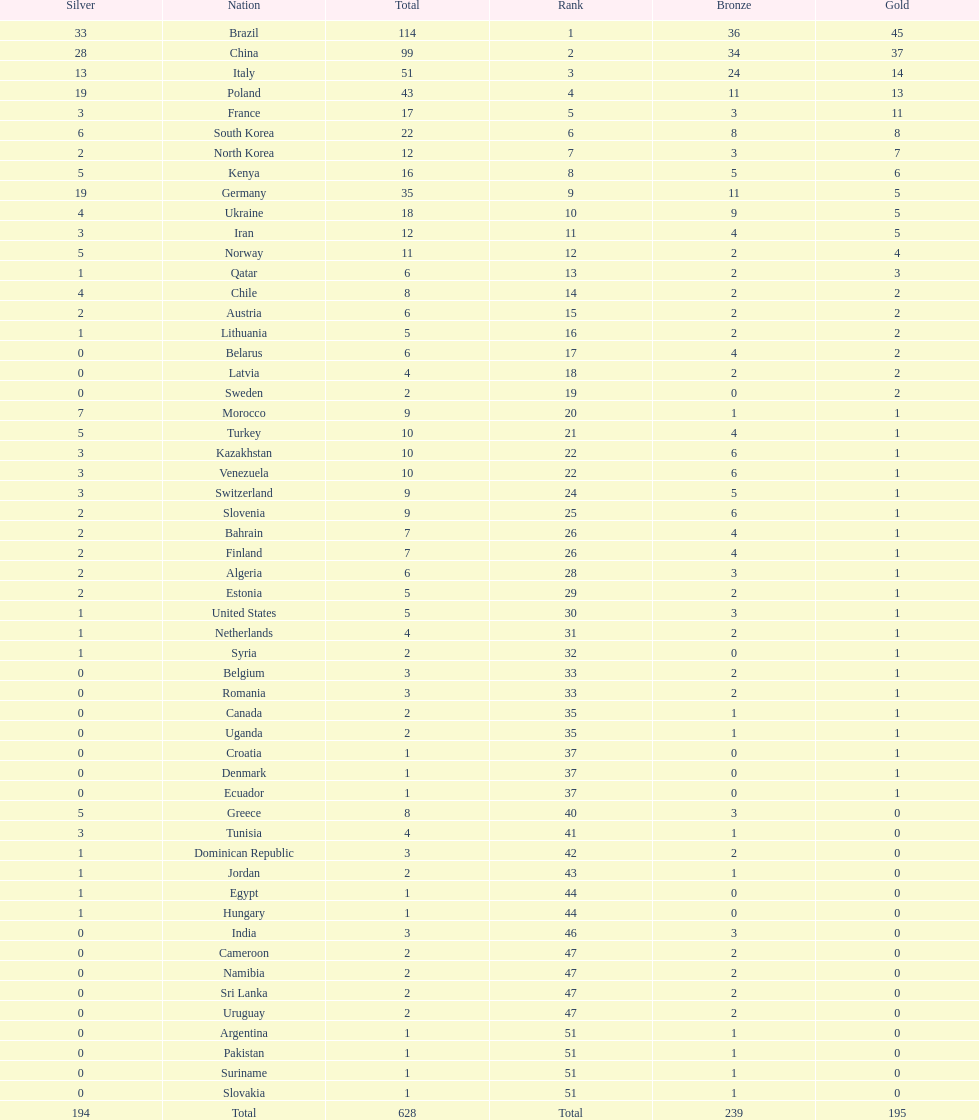Which type of medal does belarus not have? Silver. 